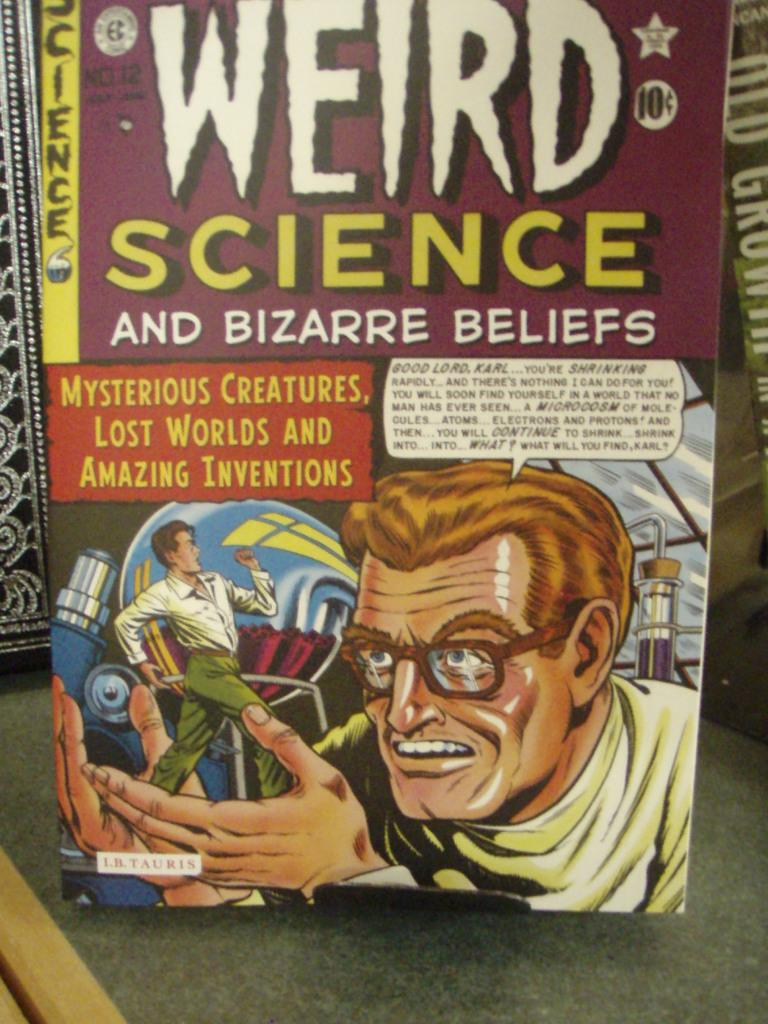<image>
Relay a brief, clear account of the picture shown. A comic book cover titled Weird Science and Bizarre Beliefs. 